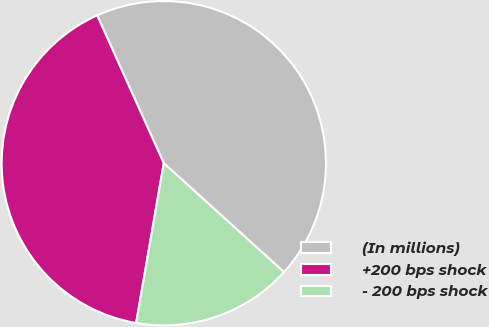Convert chart. <chart><loc_0><loc_0><loc_500><loc_500><pie_chart><fcel>(In millions)<fcel>+200 bps shock<fcel>- 200 bps shock<nl><fcel>43.45%<fcel>40.53%<fcel>16.01%<nl></chart> 